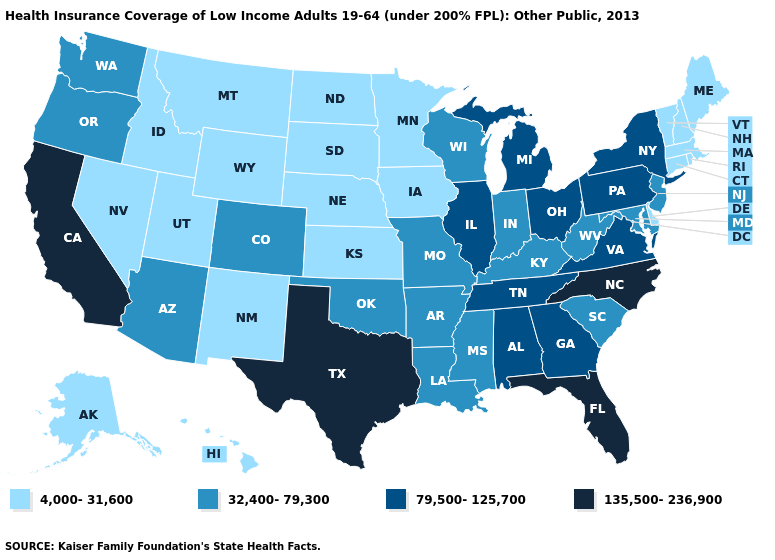Name the states that have a value in the range 4,000-31,600?
Short answer required. Alaska, Connecticut, Delaware, Hawaii, Idaho, Iowa, Kansas, Maine, Massachusetts, Minnesota, Montana, Nebraska, Nevada, New Hampshire, New Mexico, North Dakota, Rhode Island, South Dakota, Utah, Vermont, Wyoming. What is the highest value in the USA?
Write a very short answer. 135,500-236,900. Which states have the lowest value in the West?
Quick response, please. Alaska, Hawaii, Idaho, Montana, Nevada, New Mexico, Utah, Wyoming. What is the highest value in states that border Iowa?
Answer briefly. 79,500-125,700. What is the value of Kentucky?
Quick response, please. 32,400-79,300. What is the lowest value in the South?
Give a very brief answer. 4,000-31,600. Name the states that have a value in the range 135,500-236,900?
Answer briefly. California, Florida, North Carolina, Texas. Name the states that have a value in the range 79,500-125,700?
Short answer required. Alabama, Georgia, Illinois, Michigan, New York, Ohio, Pennsylvania, Tennessee, Virginia. Name the states that have a value in the range 79,500-125,700?
Give a very brief answer. Alabama, Georgia, Illinois, Michigan, New York, Ohio, Pennsylvania, Tennessee, Virginia. Name the states that have a value in the range 32,400-79,300?
Concise answer only. Arizona, Arkansas, Colorado, Indiana, Kentucky, Louisiana, Maryland, Mississippi, Missouri, New Jersey, Oklahoma, Oregon, South Carolina, Washington, West Virginia, Wisconsin. Name the states that have a value in the range 135,500-236,900?
Short answer required. California, Florida, North Carolina, Texas. What is the value of Rhode Island?
Quick response, please. 4,000-31,600. Does the first symbol in the legend represent the smallest category?
Concise answer only. Yes. Does North Carolina have the highest value in the USA?
Give a very brief answer. Yes. 